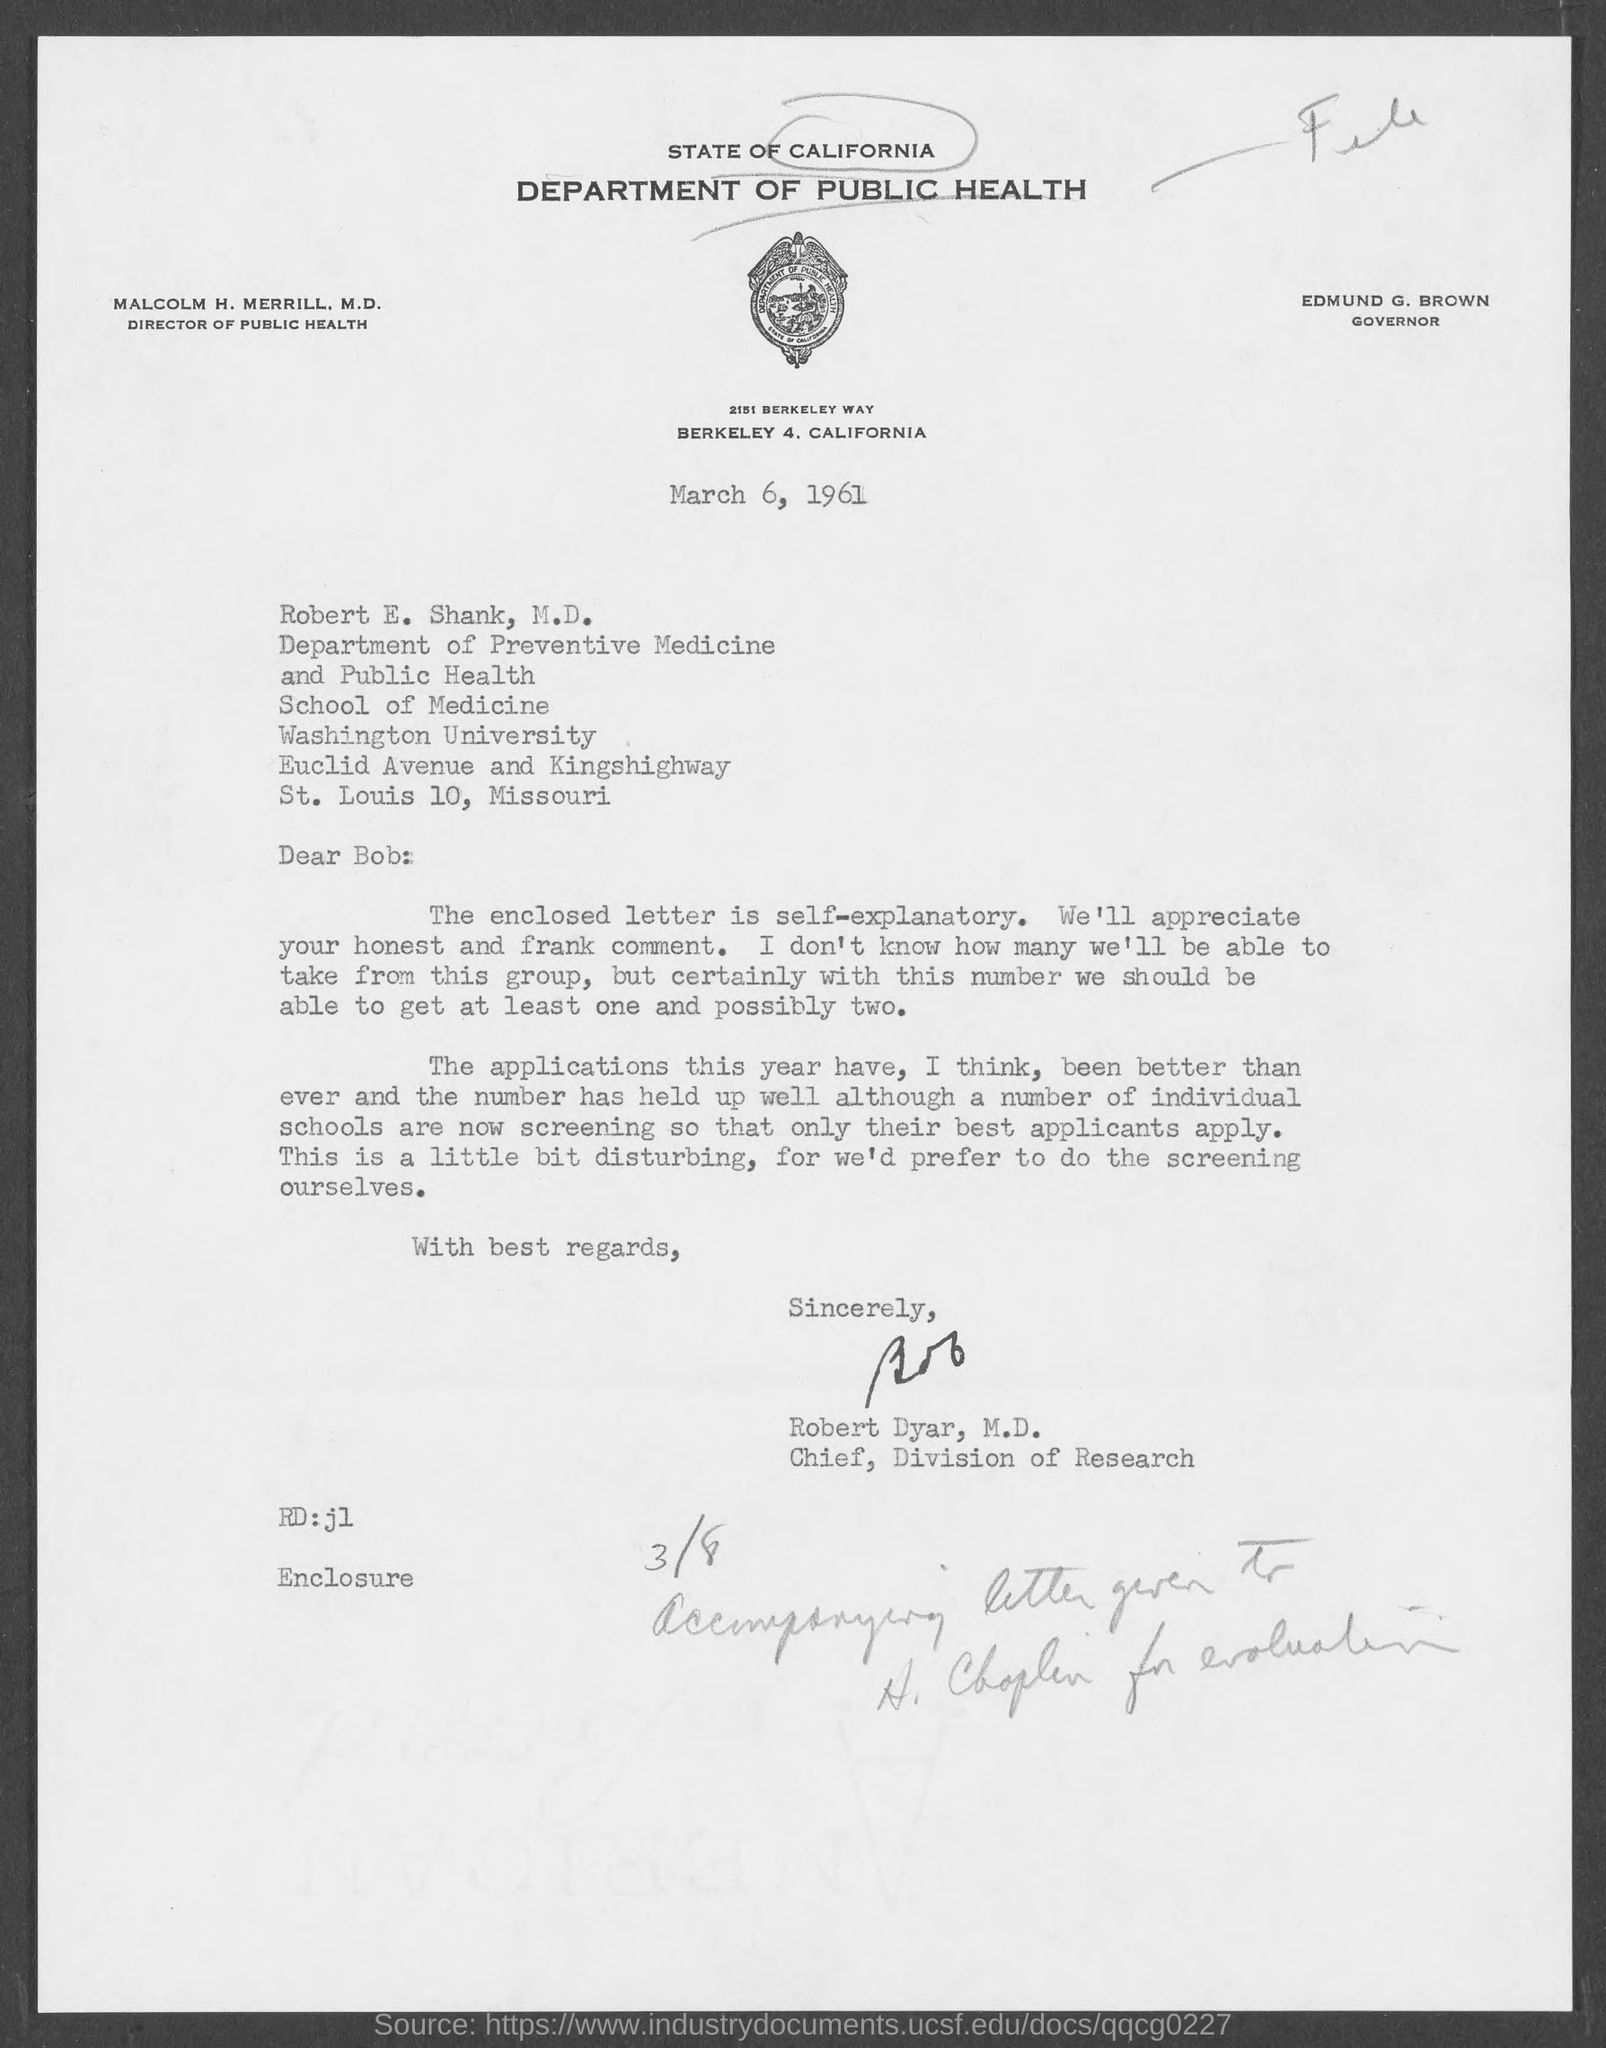Who is the director of public health, state of california?
Offer a very short reply. Malcolm H. Merrill, M.D. Who is the governor, state of california ?
Give a very brief answer. EDMUND G. BROWN. Who is the chief, division of research ?
Offer a terse response. Robert Dyar, M.D. Who wrote this letter?
Your response must be concise. Robert Dyar, M.D. 